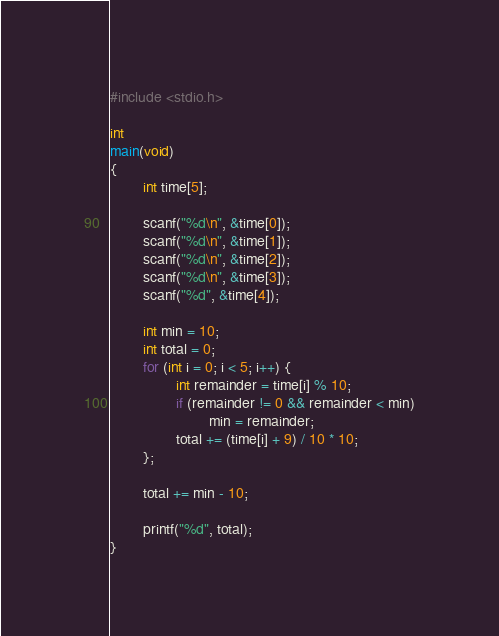Convert code to text. <code><loc_0><loc_0><loc_500><loc_500><_C_>#include <stdio.h>

int
main(void)
{
        int time[5];

        scanf("%d\n", &time[0]);
        scanf("%d\n", &time[1]);
        scanf("%d\n", &time[2]);
        scanf("%d\n", &time[3]);
        scanf("%d", &time[4]);

        int min = 10;
        int total = 0;
        for (int i = 0; i < 5; i++) {
                int remainder = time[i] % 10;
                if (remainder != 0 && remainder < min)
                        min = remainder;
                total += (time[i] + 9) / 10 * 10;
        };

        total += min - 10;

        printf("%d", total);
}
</code> 